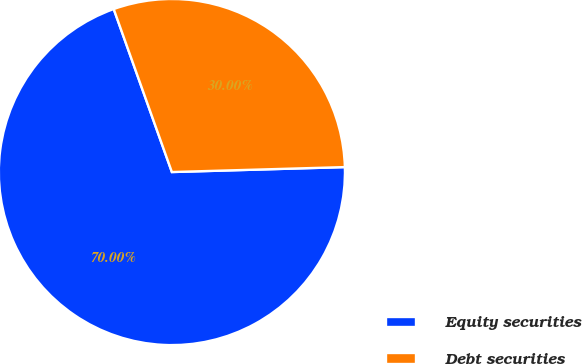<chart> <loc_0><loc_0><loc_500><loc_500><pie_chart><fcel>Equity securities<fcel>Debt securities<nl><fcel>70.0%<fcel>30.0%<nl></chart> 